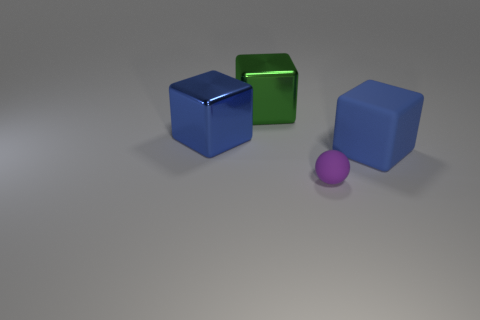Do the big matte thing and the tiny rubber sphere have the same color?
Ensure brevity in your answer.  No. What is the shape of the metallic object that is the same color as the big matte object?
Offer a very short reply. Cube. What size is the metal object that is the same color as the big matte cube?
Offer a very short reply. Large. The rubber object on the left side of the large blue matte block that is in front of the big metallic block to the right of the blue shiny cube is what color?
Your response must be concise. Purple. What is the shape of the object that is both on the left side of the big blue matte object and on the right side of the big green shiny object?
Offer a terse response. Sphere. How many other objects are there of the same shape as the purple rubber object?
Make the answer very short. 0. There is a big metallic thing that is behind the blue thing left of the thing that is right of the small matte thing; what is its shape?
Your answer should be compact. Cube. How many things are small cyan shiny spheres or big things to the right of the small purple object?
Offer a very short reply. 1. There is a small purple rubber thing that is in front of the big green shiny cube; is its shape the same as the blue object that is to the left of the green cube?
Your answer should be very brief. No. What number of objects are big matte things or cubes?
Your response must be concise. 3. 